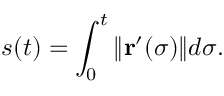<formula> <loc_0><loc_0><loc_500><loc_500>s ( t ) = \int _ { 0 } ^ { t } \| r ^ { \prime } ( \sigma ) \| d \sigma .</formula> 